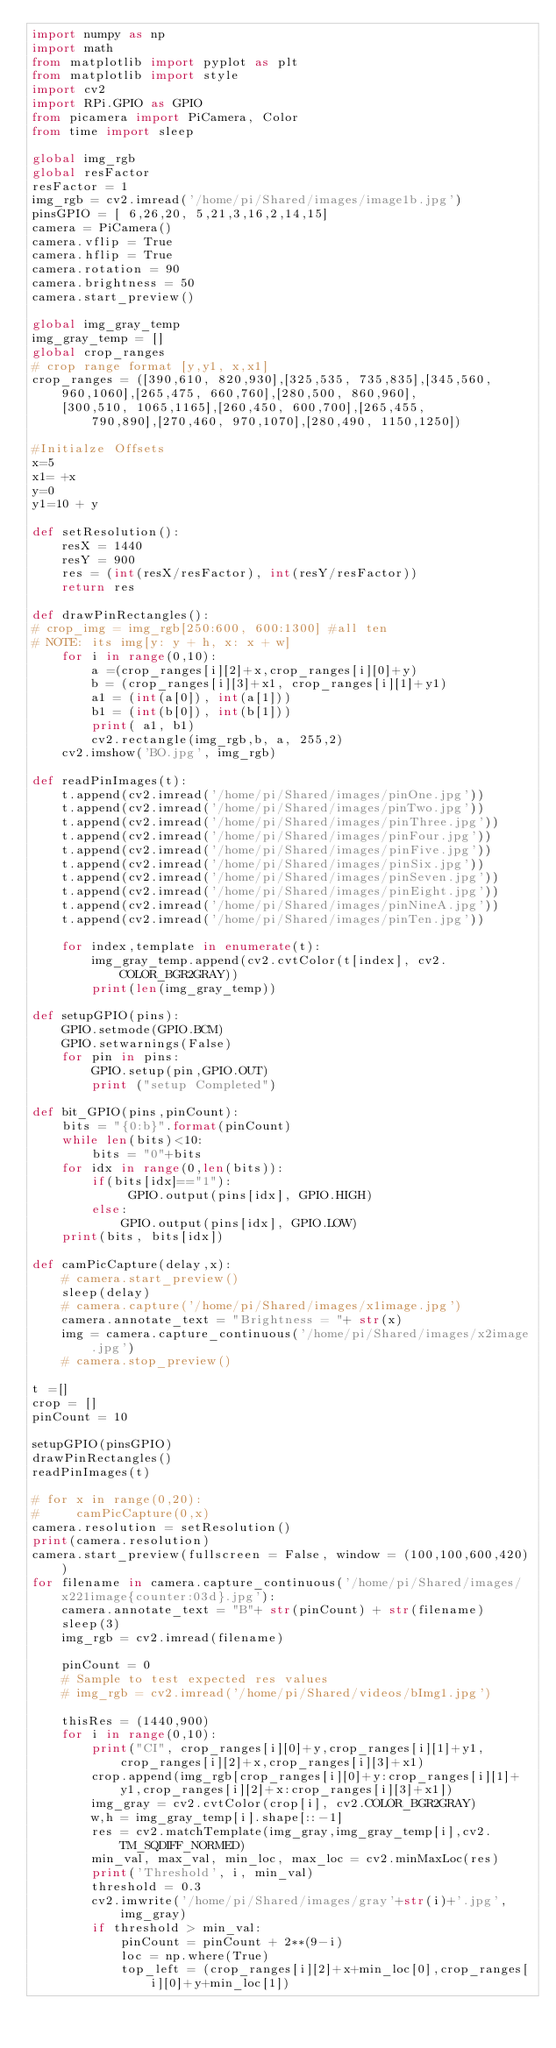<code> <loc_0><loc_0><loc_500><loc_500><_Python_>import numpy as np
import math
from matplotlib import pyplot as plt
from matplotlib import style
import cv2
import RPi.GPIO as GPIO
from picamera import PiCamera, Color
from time import sleep

global img_rgb
global resFactor
resFactor = 1
img_rgb = cv2.imread('/home/pi/Shared/images/image1b.jpg')
pinsGPIO = [ 6,26,20, 5,21,3,16,2,14,15]
camera = PiCamera()
camera.vflip = True
camera.hflip = True
camera.rotation = 90
camera.brightness = 50
camera.start_preview()

global img_gray_temp
img_gray_temp = []
global crop_ranges
# crop range format [y,y1, x,x1]
crop_ranges = ([390,610, 820,930],[325,535, 735,835],[345,560, 960,1060],[265,475, 660,760],[280,500, 860,960],
    [300,510, 1065,1165],[260,450, 600,700],[265,455, 790,890],[270,460, 970,1070],[280,490, 1150,1250])

#Initialze Offsets
x=5
x1= +x
y=0
y1=10 + y

def setResolution():
    resX = 1440
    resY = 900
    res = (int(resX/resFactor), int(resY/resFactor))
    return res

def drawPinRectangles():
# crop_img = img_rgb[250:600, 600:1300] #all ten
# NOTE: its img[y: y + h, x: x + w] 
    for i in range(0,10):
        a =(crop_ranges[i][2]+x,crop_ranges[i][0]+y)
        b = (crop_ranges[i][3]+x1, crop_ranges[i][1]+y1)
        a1 = (int(a[0]), int(a[1]))
        b1 = (int(b[0]), int(b[1]))
        print( a1, b1)
        cv2.rectangle(img_rgb,b, a, 255,2)
    cv2.imshow('BO.jpg', img_rgb) 

def readPinImages(t):
    t.append(cv2.imread('/home/pi/Shared/images/pinOne.jpg'))
    t.append(cv2.imread('/home/pi/Shared/images/pinTwo.jpg'))
    t.append(cv2.imread('/home/pi/Shared/images/pinThree.jpg'))
    t.append(cv2.imread('/home/pi/Shared/images/pinFour.jpg'))
    t.append(cv2.imread('/home/pi/Shared/images/pinFive.jpg'))
    t.append(cv2.imread('/home/pi/Shared/images/pinSix.jpg'))
    t.append(cv2.imread('/home/pi/Shared/images/pinSeven.jpg'))
    t.append(cv2.imread('/home/pi/Shared/images/pinEight.jpg'))
    t.append(cv2.imread('/home/pi/Shared/images/pinNineA.jpg'))
    t.append(cv2.imread('/home/pi/Shared/images/pinTen.jpg'))
    
    for index,template in enumerate(t):
        img_gray_temp.append(cv2.cvtColor(t[index], cv2.COLOR_BGR2GRAY))
        print(len(img_gray_temp))

def setupGPIO(pins):
    GPIO.setmode(GPIO.BCM)
    GPIO.setwarnings(False)
    for pin in pins:
        GPIO.setup(pin,GPIO.OUT)
        print ("setup Completed")

def bit_GPIO(pins,pinCount):
    bits = "{0:b}".format(pinCount)
    while len(bits)<10:
        bits = "0"+bits
    for idx in range(0,len(bits)):
        if(bits[idx]=="1"):
             GPIO.output(pins[idx], GPIO.HIGH)
        else:
            GPIO.output(pins[idx], GPIO.LOW)
    print(bits, bits[idx])

def camPicCapture(delay,x):
    # camera.start_preview()
    sleep(delay)
    # camera.capture('/home/pi/Shared/images/x1image.jpg')
    camera.annotate_text = "Brightness = "+ str(x)
    img = camera.capture_continuous('/home/pi/Shared/images/x2image.jpg')
    # camera.stop_preview()

t =[]
crop = [] 
pinCount = 10   

setupGPIO(pinsGPIO)
drawPinRectangles()
readPinImages(t)

# for x in range(0,20):
#     camPicCapture(0,x)
camera.resolution = setResolution()
print(camera.resolution)
camera.start_preview(fullscreen = False, window = (100,100,600,420))
for filename in camera.capture_continuous('/home/pi/Shared/images/x221image{counter:03d}.jpg'):
    camera.annotate_text = "B"+ str(pinCount) + str(filename) 
    sleep(3)
    img_rgb = cv2.imread(filename)
    
    pinCount = 0
    # Sample to test expected res values
    # img_rgb = cv2.imread('/home/pi/Shared/videos/bImg1.jpg')
    
    thisRes = (1440,900)
    for i in range(0,10):
        print("CI", crop_ranges[i][0]+y,crop_ranges[i][1]+y1,crop_ranges[i][2]+x,crop_ranges[i][3]+x1)
        crop.append(img_rgb[crop_ranges[i][0]+y:crop_ranges[i][1]+y1,crop_ranges[i][2]+x:crop_ranges[i][3]+x1])
        img_gray = cv2.cvtColor(crop[i], cv2.COLOR_BGR2GRAY)
        w,h = img_gray_temp[i].shape[::-1]
        res = cv2.matchTemplate(img_gray,img_gray_temp[i],cv2.TM_SQDIFF_NORMED)
        min_val, max_val, min_loc, max_loc = cv2.minMaxLoc(res)
        print('Threshold', i, min_val)
        threshold = 0.3
        cv2.imwrite('/home/pi/Shared/images/gray'+str(i)+'.jpg',img_gray)
        if threshold > min_val:
            pinCount = pinCount + 2**(9-i)
            loc = np.where(True)
            top_left = (crop_ranges[i][2]+x+min_loc[0],crop_ranges[i][0]+y+min_loc[1])</code> 